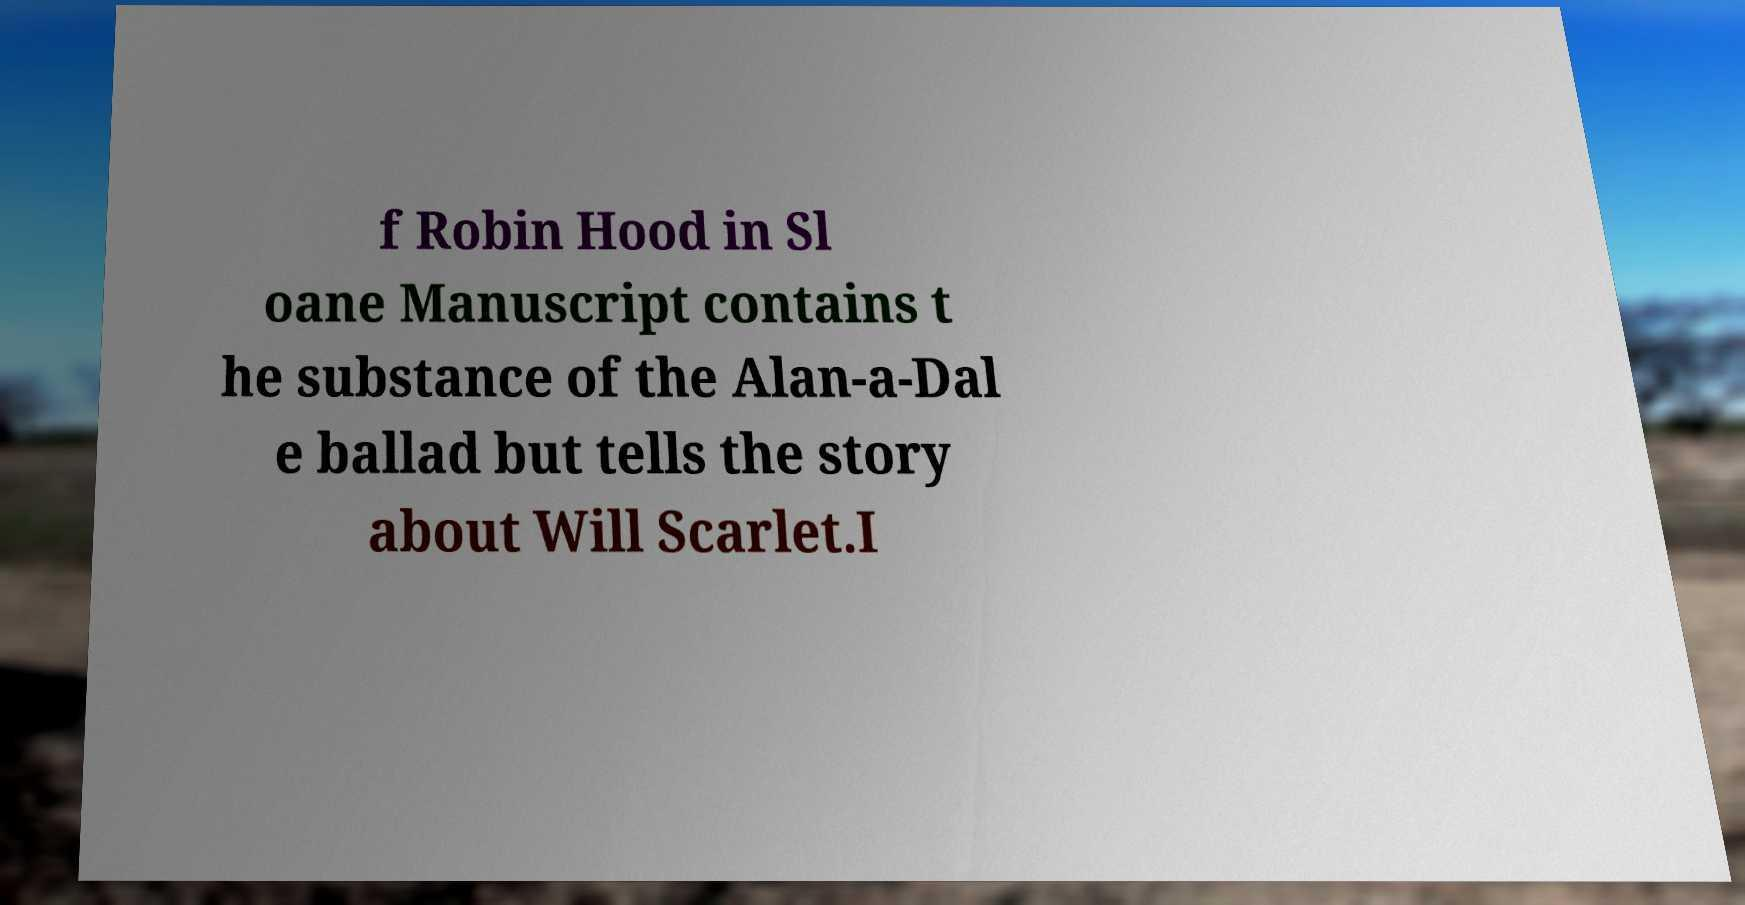I need the written content from this picture converted into text. Can you do that? f Robin Hood in Sl oane Manuscript contains t he substance of the Alan-a-Dal e ballad but tells the story about Will Scarlet.I 